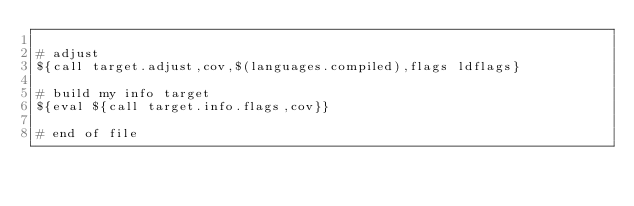Convert code to text. <code><loc_0><loc_0><loc_500><loc_500><_ObjectiveC_>
# adjust
${call target.adjust,cov,$(languages.compiled),flags ldflags}

# build my info target
${eval ${call target.info.flags,cov}}

# end of file
</code> 